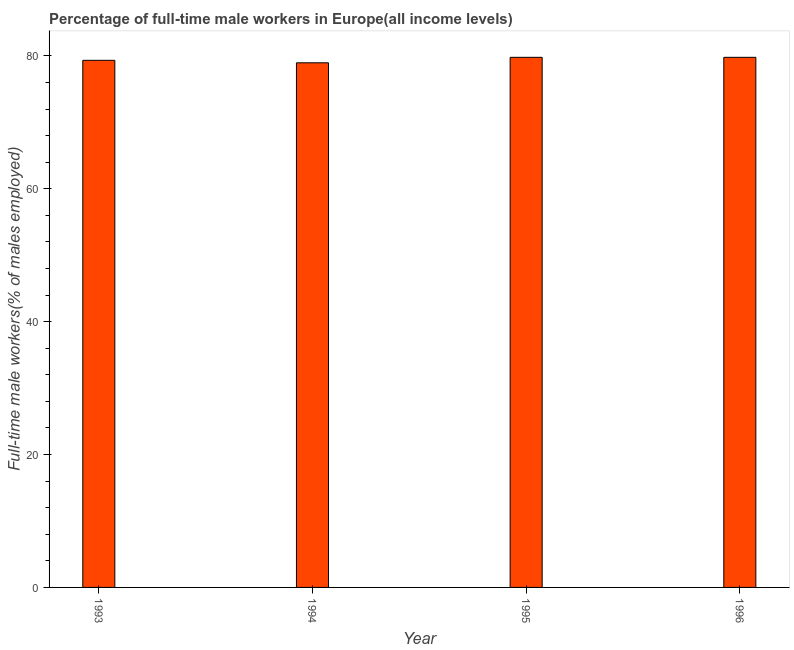Does the graph contain any zero values?
Your response must be concise. No. Does the graph contain grids?
Your answer should be compact. No. What is the title of the graph?
Your answer should be very brief. Percentage of full-time male workers in Europe(all income levels). What is the label or title of the Y-axis?
Ensure brevity in your answer.  Full-time male workers(% of males employed). What is the percentage of full-time male workers in 1993?
Provide a succinct answer. 79.34. Across all years, what is the maximum percentage of full-time male workers?
Offer a very short reply. 79.79. Across all years, what is the minimum percentage of full-time male workers?
Your answer should be very brief. 78.97. What is the sum of the percentage of full-time male workers?
Provide a short and direct response. 317.89. What is the difference between the percentage of full-time male workers in 1994 and 1995?
Your answer should be compact. -0.82. What is the average percentage of full-time male workers per year?
Offer a terse response. 79.47. What is the median percentage of full-time male workers?
Give a very brief answer. 79.57. In how many years, is the percentage of full-time male workers greater than 12 %?
Provide a succinct answer. 4. What is the ratio of the percentage of full-time male workers in 1993 to that in 1994?
Offer a very short reply. 1. Is the percentage of full-time male workers in 1994 less than that in 1995?
Make the answer very short. Yes. What is the difference between the highest and the second highest percentage of full-time male workers?
Your answer should be very brief. 0. Is the sum of the percentage of full-time male workers in 1993 and 1995 greater than the maximum percentage of full-time male workers across all years?
Keep it short and to the point. Yes. What is the difference between the highest and the lowest percentage of full-time male workers?
Make the answer very short. 0.82. Are all the bars in the graph horizontal?
Make the answer very short. No. Are the values on the major ticks of Y-axis written in scientific E-notation?
Your answer should be compact. No. What is the Full-time male workers(% of males employed) of 1993?
Provide a succinct answer. 79.34. What is the Full-time male workers(% of males employed) in 1994?
Your response must be concise. 78.97. What is the Full-time male workers(% of males employed) in 1995?
Make the answer very short. 79.79. What is the Full-time male workers(% of males employed) in 1996?
Give a very brief answer. 79.79. What is the difference between the Full-time male workers(% of males employed) in 1993 and 1994?
Offer a very short reply. 0.37. What is the difference between the Full-time male workers(% of males employed) in 1993 and 1995?
Ensure brevity in your answer.  -0.45. What is the difference between the Full-time male workers(% of males employed) in 1993 and 1996?
Give a very brief answer. -0.45. What is the difference between the Full-time male workers(% of males employed) in 1994 and 1995?
Keep it short and to the point. -0.82. What is the difference between the Full-time male workers(% of males employed) in 1994 and 1996?
Keep it short and to the point. -0.82. What is the difference between the Full-time male workers(% of males employed) in 1995 and 1996?
Provide a succinct answer. -0. What is the ratio of the Full-time male workers(% of males employed) in 1994 to that in 1995?
Your answer should be compact. 0.99. What is the ratio of the Full-time male workers(% of males employed) in 1994 to that in 1996?
Your response must be concise. 0.99. 